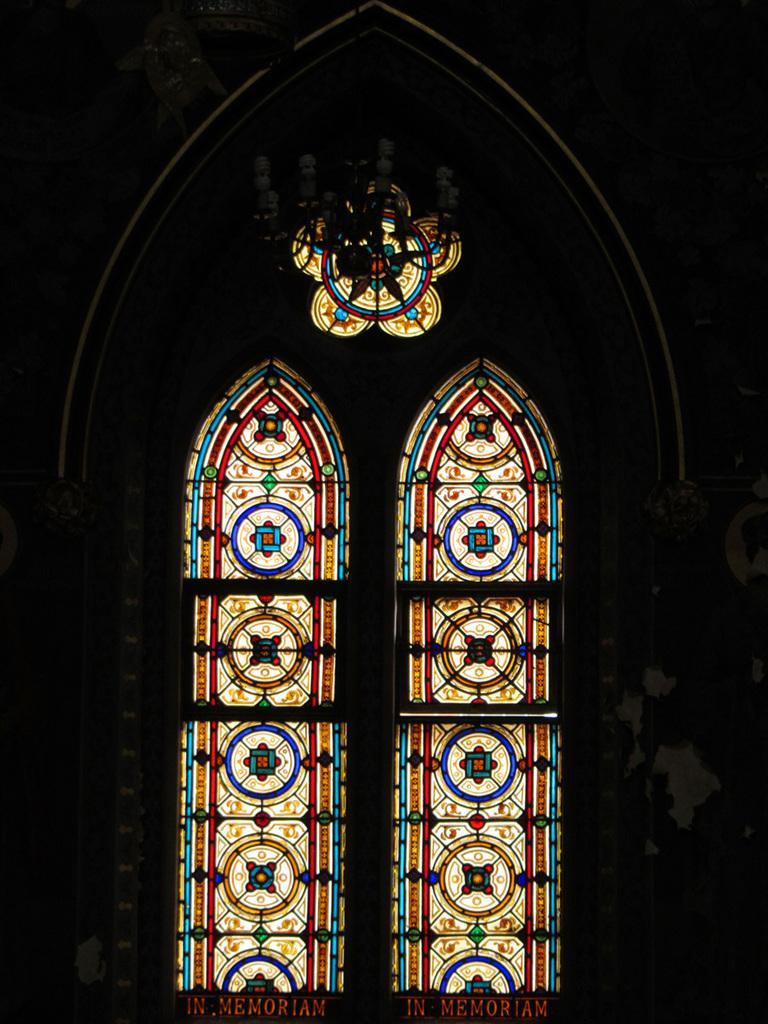Please provide a concise description of this image. In this picture we can see windows, names and some objects and in the background it is dark. 